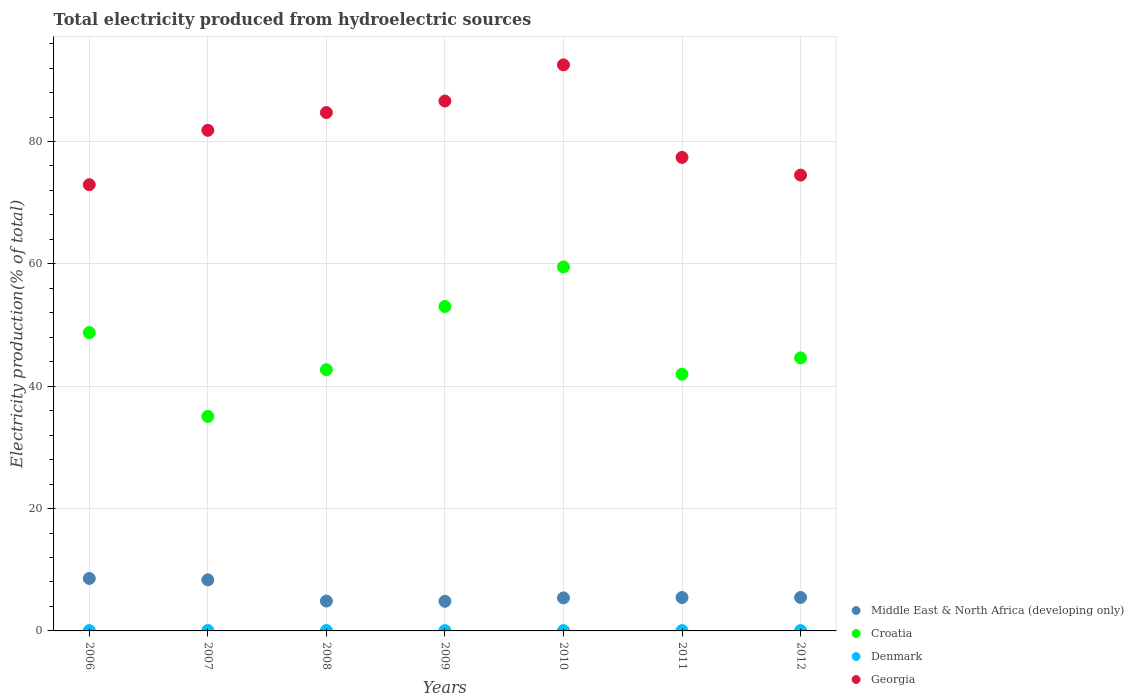How many different coloured dotlines are there?
Offer a terse response. 4. Is the number of dotlines equal to the number of legend labels?
Give a very brief answer. Yes. What is the total electricity produced in Croatia in 2011?
Ensure brevity in your answer.  41.96. Across all years, what is the maximum total electricity produced in Middle East & North Africa (developing only)?
Offer a terse response. 8.58. Across all years, what is the minimum total electricity produced in Georgia?
Provide a short and direct response. 72.94. In which year was the total electricity produced in Denmark maximum?
Make the answer very short. 2007. What is the total total electricity produced in Denmark in the graph?
Offer a very short reply. 0.4. What is the difference between the total electricity produced in Georgia in 2010 and that in 2011?
Make the answer very short. 15.12. What is the difference between the total electricity produced in Croatia in 2007 and the total electricity produced in Middle East & North Africa (developing only) in 2009?
Keep it short and to the point. 30.22. What is the average total electricity produced in Georgia per year?
Make the answer very short. 81.5. In the year 2006, what is the difference between the total electricity produced in Middle East & North Africa (developing only) and total electricity produced in Georgia?
Ensure brevity in your answer.  -64.36. In how many years, is the total electricity produced in Georgia greater than 48 %?
Keep it short and to the point. 7. What is the ratio of the total electricity produced in Croatia in 2006 to that in 2008?
Ensure brevity in your answer.  1.14. What is the difference between the highest and the second highest total electricity produced in Denmark?
Provide a short and direct response. 0. What is the difference between the highest and the lowest total electricity produced in Georgia?
Your answer should be very brief. 19.58. In how many years, is the total electricity produced in Georgia greater than the average total electricity produced in Georgia taken over all years?
Offer a terse response. 4. Is the sum of the total electricity produced in Middle East & North Africa (developing only) in 2010 and 2012 greater than the maximum total electricity produced in Denmark across all years?
Your answer should be very brief. Yes. Is it the case that in every year, the sum of the total electricity produced in Georgia and total electricity produced in Middle East & North Africa (developing only)  is greater than the total electricity produced in Denmark?
Keep it short and to the point. Yes. Does the total electricity produced in Denmark monotonically increase over the years?
Ensure brevity in your answer.  No. Is the total electricity produced in Middle East & North Africa (developing only) strictly greater than the total electricity produced in Georgia over the years?
Offer a very short reply. No. Is the total electricity produced in Middle East & North Africa (developing only) strictly less than the total electricity produced in Croatia over the years?
Your response must be concise. Yes. How many dotlines are there?
Ensure brevity in your answer.  4. How many years are there in the graph?
Ensure brevity in your answer.  7. Are the values on the major ticks of Y-axis written in scientific E-notation?
Your answer should be compact. No. Does the graph contain grids?
Give a very brief answer. Yes. How many legend labels are there?
Offer a very short reply. 4. What is the title of the graph?
Give a very brief answer. Total electricity produced from hydroelectric sources. What is the Electricity production(% of total) in Middle East & North Africa (developing only) in 2006?
Offer a terse response. 8.58. What is the Electricity production(% of total) in Croatia in 2006?
Provide a succinct answer. 48.76. What is the Electricity production(% of total) of Denmark in 2006?
Your response must be concise. 0.05. What is the Electricity production(% of total) of Georgia in 2006?
Your answer should be compact. 72.94. What is the Electricity production(% of total) of Middle East & North Africa (developing only) in 2007?
Provide a succinct answer. 8.34. What is the Electricity production(% of total) of Croatia in 2007?
Your response must be concise. 35.06. What is the Electricity production(% of total) of Denmark in 2007?
Keep it short and to the point. 0.07. What is the Electricity production(% of total) of Georgia in 2007?
Your answer should be compact. 81.83. What is the Electricity production(% of total) in Middle East & North Africa (developing only) in 2008?
Ensure brevity in your answer.  4.88. What is the Electricity production(% of total) in Croatia in 2008?
Offer a terse response. 42.7. What is the Electricity production(% of total) of Denmark in 2008?
Keep it short and to the point. 0.07. What is the Electricity production(% of total) of Georgia in 2008?
Keep it short and to the point. 84.73. What is the Electricity production(% of total) of Middle East & North Africa (developing only) in 2009?
Make the answer very short. 4.84. What is the Electricity production(% of total) in Croatia in 2009?
Offer a very short reply. 53.03. What is the Electricity production(% of total) of Denmark in 2009?
Give a very brief answer. 0.05. What is the Electricity production(% of total) of Georgia in 2009?
Your response must be concise. 86.61. What is the Electricity production(% of total) in Middle East & North Africa (developing only) in 2010?
Give a very brief answer. 5.4. What is the Electricity production(% of total) in Croatia in 2010?
Keep it short and to the point. 59.5. What is the Electricity production(% of total) in Denmark in 2010?
Provide a short and direct response. 0.05. What is the Electricity production(% of total) of Georgia in 2010?
Make the answer very short. 92.52. What is the Electricity production(% of total) in Middle East & North Africa (developing only) in 2011?
Keep it short and to the point. 5.45. What is the Electricity production(% of total) of Croatia in 2011?
Provide a succinct answer. 41.96. What is the Electricity production(% of total) in Denmark in 2011?
Your response must be concise. 0.05. What is the Electricity production(% of total) of Georgia in 2011?
Keep it short and to the point. 77.4. What is the Electricity production(% of total) of Middle East & North Africa (developing only) in 2012?
Give a very brief answer. 5.47. What is the Electricity production(% of total) in Croatia in 2012?
Provide a succinct answer. 44.63. What is the Electricity production(% of total) in Denmark in 2012?
Your answer should be compact. 0.06. What is the Electricity production(% of total) of Georgia in 2012?
Offer a terse response. 74.5. Across all years, what is the maximum Electricity production(% of total) of Middle East & North Africa (developing only)?
Make the answer very short. 8.58. Across all years, what is the maximum Electricity production(% of total) in Croatia?
Your answer should be compact. 59.5. Across all years, what is the maximum Electricity production(% of total) of Denmark?
Offer a very short reply. 0.07. Across all years, what is the maximum Electricity production(% of total) in Georgia?
Provide a succinct answer. 92.52. Across all years, what is the minimum Electricity production(% of total) in Middle East & North Africa (developing only)?
Give a very brief answer. 4.84. Across all years, what is the minimum Electricity production(% of total) in Croatia?
Your response must be concise. 35.06. Across all years, what is the minimum Electricity production(% of total) in Denmark?
Your answer should be very brief. 0.05. Across all years, what is the minimum Electricity production(% of total) in Georgia?
Your answer should be very brief. 72.94. What is the total Electricity production(% of total) in Middle East & North Africa (developing only) in the graph?
Your response must be concise. 42.97. What is the total Electricity production(% of total) of Croatia in the graph?
Give a very brief answer. 325.64. What is the total Electricity production(% of total) in Denmark in the graph?
Offer a very short reply. 0.4. What is the total Electricity production(% of total) in Georgia in the graph?
Give a very brief answer. 570.53. What is the difference between the Electricity production(% of total) in Middle East & North Africa (developing only) in 2006 and that in 2007?
Ensure brevity in your answer.  0.23. What is the difference between the Electricity production(% of total) of Croatia in 2006 and that in 2007?
Your response must be concise. 13.69. What is the difference between the Electricity production(% of total) of Denmark in 2006 and that in 2007?
Make the answer very short. -0.02. What is the difference between the Electricity production(% of total) in Georgia in 2006 and that in 2007?
Offer a terse response. -8.89. What is the difference between the Electricity production(% of total) in Middle East & North Africa (developing only) in 2006 and that in 2008?
Provide a succinct answer. 3.7. What is the difference between the Electricity production(% of total) in Croatia in 2006 and that in 2008?
Keep it short and to the point. 6.06. What is the difference between the Electricity production(% of total) in Denmark in 2006 and that in 2008?
Ensure brevity in your answer.  -0.02. What is the difference between the Electricity production(% of total) in Georgia in 2006 and that in 2008?
Your answer should be compact. -11.79. What is the difference between the Electricity production(% of total) of Middle East & North Africa (developing only) in 2006 and that in 2009?
Give a very brief answer. 3.74. What is the difference between the Electricity production(% of total) of Croatia in 2006 and that in 2009?
Provide a short and direct response. -4.27. What is the difference between the Electricity production(% of total) in Denmark in 2006 and that in 2009?
Your response must be concise. -0. What is the difference between the Electricity production(% of total) of Georgia in 2006 and that in 2009?
Keep it short and to the point. -13.67. What is the difference between the Electricity production(% of total) of Middle East & North Africa (developing only) in 2006 and that in 2010?
Ensure brevity in your answer.  3.18. What is the difference between the Electricity production(% of total) in Croatia in 2006 and that in 2010?
Your response must be concise. -10.74. What is the difference between the Electricity production(% of total) in Denmark in 2006 and that in 2010?
Offer a terse response. -0. What is the difference between the Electricity production(% of total) of Georgia in 2006 and that in 2010?
Ensure brevity in your answer.  -19.58. What is the difference between the Electricity production(% of total) in Middle East & North Africa (developing only) in 2006 and that in 2011?
Offer a very short reply. 3.12. What is the difference between the Electricity production(% of total) in Croatia in 2006 and that in 2011?
Your answer should be compact. 6.79. What is the difference between the Electricity production(% of total) in Denmark in 2006 and that in 2011?
Provide a succinct answer. 0. What is the difference between the Electricity production(% of total) of Georgia in 2006 and that in 2011?
Your answer should be compact. -4.46. What is the difference between the Electricity production(% of total) of Middle East & North Africa (developing only) in 2006 and that in 2012?
Your answer should be compact. 3.1. What is the difference between the Electricity production(% of total) of Croatia in 2006 and that in 2012?
Make the answer very short. 4.13. What is the difference between the Electricity production(% of total) in Denmark in 2006 and that in 2012?
Make the answer very short. -0. What is the difference between the Electricity production(% of total) of Georgia in 2006 and that in 2012?
Provide a short and direct response. -1.56. What is the difference between the Electricity production(% of total) in Middle East & North Africa (developing only) in 2007 and that in 2008?
Provide a succinct answer. 3.47. What is the difference between the Electricity production(% of total) of Croatia in 2007 and that in 2008?
Provide a succinct answer. -7.63. What is the difference between the Electricity production(% of total) in Denmark in 2007 and that in 2008?
Offer a very short reply. 0. What is the difference between the Electricity production(% of total) of Georgia in 2007 and that in 2008?
Offer a terse response. -2.9. What is the difference between the Electricity production(% of total) in Middle East & North Africa (developing only) in 2007 and that in 2009?
Offer a very short reply. 3.5. What is the difference between the Electricity production(% of total) in Croatia in 2007 and that in 2009?
Ensure brevity in your answer.  -17.97. What is the difference between the Electricity production(% of total) of Denmark in 2007 and that in 2009?
Your response must be concise. 0.02. What is the difference between the Electricity production(% of total) of Georgia in 2007 and that in 2009?
Your answer should be very brief. -4.78. What is the difference between the Electricity production(% of total) of Middle East & North Africa (developing only) in 2007 and that in 2010?
Give a very brief answer. 2.94. What is the difference between the Electricity production(% of total) in Croatia in 2007 and that in 2010?
Offer a terse response. -24.43. What is the difference between the Electricity production(% of total) in Denmark in 2007 and that in 2010?
Keep it short and to the point. 0.02. What is the difference between the Electricity production(% of total) of Georgia in 2007 and that in 2010?
Your answer should be very brief. -10.69. What is the difference between the Electricity production(% of total) in Middle East & North Africa (developing only) in 2007 and that in 2011?
Provide a succinct answer. 2.89. What is the difference between the Electricity production(% of total) of Croatia in 2007 and that in 2011?
Offer a terse response. -6.9. What is the difference between the Electricity production(% of total) of Denmark in 2007 and that in 2011?
Keep it short and to the point. 0.02. What is the difference between the Electricity production(% of total) in Georgia in 2007 and that in 2011?
Your response must be concise. 4.43. What is the difference between the Electricity production(% of total) in Middle East & North Africa (developing only) in 2007 and that in 2012?
Your answer should be very brief. 2.87. What is the difference between the Electricity production(% of total) in Croatia in 2007 and that in 2012?
Provide a succinct answer. -9.56. What is the difference between the Electricity production(% of total) of Denmark in 2007 and that in 2012?
Give a very brief answer. 0.02. What is the difference between the Electricity production(% of total) in Georgia in 2007 and that in 2012?
Give a very brief answer. 7.33. What is the difference between the Electricity production(% of total) of Middle East & North Africa (developing only) in 2008 and that in 2009?
Ensure brevity in your answer.  0.04. What is the difference between the Electricity production(% of total) of Croatia in 2008 and that in 2009?
Provide a short and direct response. -10.33. What is the difference between the Electricity production(% of total) of Denmark in 2008 and that in 2009?
Your answer should be compact. 0.02. What is the difference between the Electricity production(% of total) in Georgia in 2008 and that in 2009?
Your answer should be compact. -1.88. What is the difference between the Electricity production(% of total) of Middle East & North Africa (developing only) in 2008 and that in 2010?
Your response must be concise. -0.52. What is the difference between the Electricity production(% of total) in Croatia in 2008 and that in 2010?
Give a very brief answer. -16.8. What is the difference between the Electricity production(% of total) of Denmark in 2008 and that in 2010?
Your response must be concise. 0.02. What is the difference between the Electricity production(% of total) in Georgia in 2008 and that in 2010?
Offer a terse response. -7.8. What is the difference between the Electricity production(% of total) of Middle East & North Africa (developing only) in 2008 and that in 2011?
Offer a very short reply. -0.57. What is the difference between the Electricity production(% of total) in Croatia in 2008 and that in 2011?
Make the answer very short. 0.73. What is the difference between the Electricity production(% of total) in Denmark in 2008 and that in 2011?
Give a very brief answer. 0.02. What is the difference between the Electricity production(% of total) of Georgia in 2008 and that in 2011?
Your response must be concise. 7.33. What is the difference between the Electricity production(% of total) of Middle East & North Africa (developing only) in 2008 and that in 2012?
Your response must be concise. -0.59. What is the difference between the Electricity production(% of total) in Croatia in 2008 and that in 2012?
Keep it short and to the point. -1.93. What is the difference between the Electricity production(% of total) of Denmark in 2008 and that in 2012?
Your answer should be compact. 0.02. What is the difference between the Electricity production(% of total) of Georgia in 2008 and that in 2012?
Provide a succinct answer. 10.22. What is the difference between the Electricity production(% of total) in Middle East & North Africa (developing only) in 2009 and that in 2010?
Offer a very short reply. -0.56. What is the difference between the Electricity production(% of total) in Croatia in 2009 and that in 2010?
Your response must be concise. -6.47. What is the difference between the Electricity production(% of total) in Denmark in 2009 and that in 2010?
Provide a short and direct response. -0. What is the difference between the Electricity production(% of total) of Georgia in 2009 and that in 2010?
Provide a short and direct response. -5.91. What is the difference between the Electricity production(% of total) in Middle East & North Africa (developing only) in 2009 and that in 2011?
Give a very brief answer. -0.61. What is the difference between the Electricity production(% of total) in Croatia in 2009 and that in 2011?
Make the answer very short. 11.07. What is the difference between the Electricity production(% of total) of Denmark in 2009 and that in 2011?
Make the answer very short. 0. What is the difference between the Electricity production(% of total) in Georgia in 2009 and that in 2011?
Provide a succinct answer. 9.21. What is the difference between the Electricity production(% of total) of Middle East & North Africa (developing only) in 2009 and that in 2012?
Offer a very short reply. -0.63. What is the difference between the Electricity production(% of total) in Croatia in 2009 and that in 2012?
Provide a succinct answer. 8.4. What is the difference between the Electricity production(% of total) of Denmark in 2009 and that in 2012?
Offer a terse response. -0. What is the difference between the Electricity production(% of total) in Georgia in 2009 and that in 2012?
Provide a succinct answer. 12.11. What is the difference between the Electricity production(% of total) in Middle East & North Africa (developing only) in 2010 and that in 2011?
Offer a very short reply. -0.05. What is the difference between the Electricity production(% of total) in Croatia in 2010 and that in 2011?
Your answer should be very brief. 17.53. What is the difference between the Electricity production(% of total) in Denmark in 2010 and that in 2011?
Ensure brevity in your answer.  0.01. What is the difference between the Electricity production(% of total) of Georgia in 2010 and that in 2011?
Your answer should be very brief. 15.12. What is the difference between the Electricity production(% of total) in Middle East & North Africa (developing only) in 2010 and that in 2012?
Your answer should be very brief. -0.07. What is the difference between the Electricity production(% of total) in Croatia in 2010 and that in 2012?
Give a very brief answer. 14.87. What is the difference between the Electricity production(% of total) in Denmark in 2010 and that in 2012?
Offer a very short reply. -0. What is the difference between the Electricity production(% of total) of Georgia in 2010 and that in 2012?
Offer a very short reply. 18.02. What is the difference between the Electricity production(% of total) of Middle East & North Africa (developing only) in 2011 and that in 2012?
Offer a terse response. -0.02. What is the difference between the Electricity production(% of total) of Croatia in 2011 and that in 2012?
Give a very brief answer. -2.66. What is the difference between the Electricity production(% of total) of Denmark in 2011 and that in 2012?
Your answer should be very brief. -0.01. What is the difference between the Electricity production(% of total) in Georgia in 2011 and that in 2012?
Ensure brevity in your answer.  2.9. What is the difference between the Electricity production(% of total) of Middle East & North Africa (developing only) in 2006 and the Electricity production(% of total) of Croatia in 2007?
Your answer should be compact. -26.49. What is the difference between the Electricity production(% of total) of Middle East & North Africa (developing only) in 2006 and the Electricity production(% of total) of Denmark in 2007?
Your answer should be very brief. 8.51. What is the difference between the Electricity production(% of total) of Middle East & North Africa (developing only) in 2006 and the Electricity production(% of total) of Georgia in 2007?
Provide a short and direct response. -73.25. What is the difference between the Electricity production(% of total) of Croatia in 2006 and the Electricity production(% of total) of Denmark in 2007?
Your response must be concise. 48.69. What is the difference between the Electricity production(% of total) in Croatia in 2006 and the Electricity production(% of total) in Georgia in 2007?
Offer a very short reply. -33.07. What is the difference between the Electricity production(% of total) of Denmark in 2006 and the Electricity production(% of total) of Georgia in 2007?
Give a very brief answer. -81.78. What is the difference between the Electricity production(% of total) of Middle East & North Africa (developing only) in 2006 and the Electricity production(% of total) of Croatia in 2008?
Provide a short and direct response. -34.12. What is the difference between the Electricity production(% of total) in Middle East & North Africa (developing only) in 2006 and the Electricity production(% of total) in Denmark in 2008?
Ensure brevity in your answer.  8.51. What is the difference between the Electricity production(% of total) in Middle East & North Africa (developing only) in 2006 and the Electricity production(% of total) in Georgia in 2008?
Ensure brevity in your answer.  -76.15. What is the difference between the Electricity production(% of total) of Croatia in 2006 and the Electricity production(% of total) of Denmark in 2008?
Provide a succinct answer. 48.69. What is the difference between the Electricity production(% of total) in Croatia in 2006 and the Electricity production(% of total) in Georgia in 2008?
Provide a short and direct response. -35.97. What is the difference between the Electricity production(% of total) of Denmark in 2006 and the Electricity production(% of total) of Georgia in 2008?
Make the answer very short. -84.68. What is the difference between the Electricity production(% of total) of Middle East & North Africa (developing only) in 2006 and the Electricity production(% of total) of Croatia in 2009?
Provide a succinct answer. -44.45. What is the difference between the Electricity production(% of total) in Middle East & North Africa (developing only) in 2006 and the Electricity production(% of total) in Denmark in 2009?
Your answer should be compact. 8.53. What is the difference between the Electricity production(% of total) in Middle East & North Africa (developing only) in 2006 and the Electricity production(% of total) in Georgia in 2009?
Make the answer very short. -78.03. What is the difference between the Electricity production(% of total) in Croatia in 2006 and the Electricity production(% of total) in Denmark in 2009?
Give a very brief answer. 48.7. What is the difference between the Electricity production(% of total) in Croatia in 2006 and the Electricity production(% of total) in Georgia in 2009?
Provide a succinct answer. -37.85. What is the difference between the Electricity production(% of total) in Denmark in 2006 and the Electricity production(% of total) in Georgia in 2009?
Offer a very short reply. -86.56. What is the difference between the Electricity production(% of total) in Middle East & North Africa (developing only) in 2006 and the Electricity production(% of total) in Croatia in 2010?
Your answer should be compact. -50.92. What is the difference between the Electricity production(% of total) of Middle East & North Africa (developing only) in 2006 and the Electricity production(% of total) of Denmark in 2010?
Provide a succinct answer. 8.52. What is the difference between the Electricity production(% of total) in Middle East & North Africa (developing only) in 2006 and the Electricity production(% of total) in Georgia in 2010?
Offer a terse response. -83.95. What is the difference between the Electricity production(% of total) in Croatia in 2006 and the Electricity production(% of total) in Denmark in 2010?
Provide a succinct answer. 48.7. What is the difference between the Electricity production(% of total) of Croatia in 2006 and the Electricity production(% of total) of Georgia in 2010?
Give a very brief answer. -43.77. What is the difference between the Electricity production(% of total) in Denmark in 2006 and the Electricity production(% of total) in Georgia in 2010?
Provide a short and direct response. -92.47. What is the difference between the Electricity production(% of total) of Middle East & North Africa (developing only) in 2006 and the Electricity production(% of total) of Croatia in 2011?
Your answer should be very brief. -33.39. What is the difference between the Electricity production(% of total) of Middle East & North Africa (developing only) in 2006 and the Electricity production(% of total) of Denmark in 2011?
Ensure brevity in your answer.  8.53. What is the difference between the Electricity production(% of total) in Middle East & North Africa (developing only) in 2006 and the Electricity production(% of total) in Georgia in 2011?
Provide a short and direct response. -68.82. What is the difference between the Electricity production(% of total) of Croatia in 2006 and the Electricity production(% of total) of Denmark in 2011?
Your response must be concise. 48.71. What is the difference between the Electricity production(% of total) in Croatia in 2006 and the Electricity production(% of total) in Georgia in 2011?
Your answer should be compact. -28.64. What is the difference between the Electricity production(% of total) in Denmark in 2006 and the Electricity production(% of total) in Georgia in 2011?
Your answer should be very brief. -77.35. What is the difference between the Electricity production(% of total) of Middle East & North Africa (developing only) in 2006 and the Electricity production(% of total) of Croatia in 2012?
Make the answer very short. -36.05. What is the difference between the Electricity production(% of total) in Middle East & North Africa (developing only) in 2006 and the Electricity production(% of total) in Denmark in 2012?
Make the answer very short. 8.52. What is the difference between the Electricity production(% of total) of Middle East & North Africa (developing only) in 2006 and the Electricity production(% of total) of Georgia in 2012?
Keep it short and to the point. -65.92. What is the difference between the Electricity production(% of total) of Croatia in 2006 and the Electricity production(% of total) of Denmark in 2012?
Offer a terse response. 48.7. What is the difference between the Electricity production(% of total) of Croatia in 2006 and the Electricity production(% of total) of Georgia in 2012?
Provide a short and direct response. -25.75. What is the difference between the Electricity production(% of total) of Denmark in 2006 and the Electricity production(% of total) of Georgia in 2012?
Make the answer very short. -74.45. What is the difference between the Electricity production(% of total) in Middle East & North Africa (developing only) in 2007 and the Electricity production(% of total) in Croatia in 2008?
Ensure brevity in your answer.  -34.35. What is the difference between the Electricity production(% of total) in Middle East & North Africa (developing only) in 2007 and the Electricity production(% of total) in Denmark in 2008?
Offer a terse response. 8.27. What is the difference between the Electricity production(% of total) of Middle East & North Africa (developing only) in 2007 and the Electricity production(% of total) of Georgia in 2008?
Keep it short and to the point. -76.38. What is the difference between the Electricity production(% of total) of Croatia in 2007 and the Electricity production(% of total) of Denmark in 2008?
Your answer should be very brief. 34.99. What is the difference between the Electricity production(% of total) of Croatia in 2007 and the Electricity production(% of total) of Georgia in 2008?
Your answer should be very brief. -49.66. What is the difference between the Electricity production(% of total) of Denmark in 2007 and the Electricity production(% of total) of Georgia in 2008?
Offer a terse response. -84.66. What is the difference between the Electricity production(% of total) of Middle East & North Africa (developing only) in 2007 and the Electricity production(% of total) of Croatia in 2009?
Give a very brief answer. -44.69. What is the difference between the Electricity production(% of total) of Middle East & North Africa (developing only) in 2007 and the Electricity production(% of total) of Denmark in 2009?
Provide a succinct answer. 8.29. What is the difference between the Electricity production(% of total) in Middle East & North Africa (developing only) in 2007 and the Electricity production(% of total) in Georgia in 2009?
Provide a succinct answer. -78.26. What is the difference between the Electricity production(% of total) of Croatia in 2007 and the Electricity production(% of total) of Denmark in 2009?
Make the answer very short. 35.01. What is the difference between the Electricity production(% of total) of Croatia in 2007 and the Electricity production(% of total) of Georgia in 2009?
Provide a succinct answer. -51.55. What is the difference between the Electricity production(% of total) in Denmark in 2007 and the Electricity production(% of total) in Georgia in 2009?
Make the answer very short. -86.54. What is the difference between the Electricity production(% of total) of Middle East & North Africa (developing only) in 2007 and the Electricity production(% of total) of Croatia in 2010?
Keep it short and to the point. -51.15. What is the difference between the Electricity production(% of total) in Middle East & North Africa (developing only) in 2007 and the Electricity production(% of total) in Denmark in 2010?
Offer a very short reply. 8.29. What is the difference between the Electricity production(% of total) of Middle East & North Africa (developing only) in 2007 and the Electricity production(% of total) of Georgia in 2010?
Offer a terse response. -84.18. What is the difference between the Electricity production(% of total) of Croatia in 2007 and the Electricity production(% of total) of Denmark in 2010?
Offer a terse response. 35.01. What is the difference between the Electricity production(% of total) of Croatia in 2007 and the Electricity production(% of total) of Georgia in 2010?
Provide a short and direct response. -57.46. What is the difference between the Electricity production(% of total) of Denmark in 2007 and the Electricity production(% of total) of Georgia in 2010?
Your answer should be very brief. -92.45. What is the difference between the Electricity production(% of total) in Middle East & North Africa (developing only) in 2007 and the Electricity production(% of total) in Croatia in 2011?
Make the answer very short. -33.62. What is the difference between the Electricity production(% of total) of Middle East & North Africa (developing only) in 2007 and the Electricity production(% of total) of Denmark in 2011?
Offer a very short reply. 8.3. What is the difference between the Electricity production(% of total) of Middle East & North Africa (developing only) in 2007 and the Electricity production(% of total) of Georgia in 2011?
Your answer should be compact. -69.05. What is the difference between the Electricity production(% of total) in Croatia in 2007 and the Electricity production(% of total) in Denmark in 2011?
Your answer should be compact. 35.02. What is the difference between the Electricity production(% of total) of Croatia in 2007 and the Electricity production(% of total) of Georgia in 2011?
Offer a terse response. -42.34. What is the difference between the Electricity production(% of total) of Denmark in 2007 and the Electricity production(% of total) of Georgia in 2011?
Provide a short and direct response. -77.33. What is the difference between the Electricity production(% of total) in Middle East & North Africa (developing only) in 2007 and the Electricity production(% of total) in Croatia in 2012?
Your answer should be compact. -36.28. What is the difference between the Electricity production(% of total) in Middle East & North Africa (developing only) in 2007 and the Electricity production(% of total) in Denmark in 2012?
Offer a very short reply. 8.29. What is the difference between the Electricity production(% of total) of Middle East & North Africa (developing only) in 2007 and the Electricity production(% of total) of Georgia in 2012?
Offer a very short reply. -66.16. What is the difference between the Electricity production(% of total) of Croatia in 2007 and the Electricity production(% of total) of Denmark in 2012?
Keep it short and to the point. 35.01. What is the difference between the Electricity production(% of total) in Croatia in 2007 and the Electricity production(% of total) in Georgia in 2012?
Ensure brevity in your answer.  -39.44. What is the difference between the Electricity production(% of total) of Denmark in 2007 and the Electricity production(% of total) of Georgia in 2012?
Make the answer very short. -74.43. What is the difference between the Electricity production(% of total) in Middle East & North Africa (developing only) in 2008 and the Electricity production(% of total) in Croatia in 2009?
Provide a short and direct response. -48.15. What is the difference between the Electricity production(% of total) of Middle East & North Africa (developing only) in 2008 and the Electricity production(% of total) of Denmark in 2009?
Provide a short and direct response. 4.83. What is the difference between the Electricity production(% of total) of Middle East & North Africa (developing only) in 2008 and the Electricity production(% of total) of Georgia in 2009?
Provide a succinct answer. -81.73. What is the difference between the Electricity production(% of total) in Croatia in 2008 and the Electricity production(% of total) in Denmark in 2009?
Make the answer very short. 42.65. What is the difference between the Electricity production(% of total) in Croatia in 2008 and the Electricity production(% of total) in Georgia in 2009?
Offer a terse response. -43.91. What is the difference between the Electricity production(% of total) in Denmark in 2008 and the Electricity production(% of total) in Georgia in 2009?
Keep it short and to the point. -86.54. What is the difference between the Electricity production(% of total) of Middle East & North Africa (developing only) in 2008 and the Electricity production(% of total) of Croatia in 2010?
Keep it short and to the point. -54.62. What is the difference between the Electricity production(% of total) in Middle East & North Africa (developing only) in 2008 and the Electricity production(% of total) in Denmark in 2010?
Your response must be concise. 4.83. What is the difference between the Electricity production(% of total) of Middle East & North Africa (developing only) in 2008 and the Electricity production(% of total) of Georgia in 2010?
Offer a terse response. -87.64. What is the difference between the Electricity production(% of total) in Croatia in 2008 and the Electricity production(% of total) in Denmark in 2010?
Make the answer very short. 42.64. What is the difference between the Electricity production(% of total) of Croatia in 2008 and the Electricity production(% of total) of Georgia in 2010?
Keep it short and to the point. -49.82. What is the difference between the Electricity production(% of total) in Denmark in 2008 and the Electricity production(% of total) in Georgia in 2010?
Make the answer very short. -92.45. What is the difference between the Electricity production(% of total) in Middle East & North Africa (developing only) in 2008 and the Electricity production(% of total) in Croatia in 2011?
Make the answer very short. -37.08. What is the difference between the Electricity production(% of total) of Middle East & North Africa (developing only) in 2008 and the Electricity production(% of total) of Denmark in 2011?
Provide a succinct answer. 4.83. What is the difference between the Electricity production(% of total) of Middle East & North Africa (developing only) in 2008 and the Electricity production(% of total) of Georgia in 2011?
Your response must be concise. -72.52. What is the difference between the Electricity production(% of total) in Croatia in 2008 and the Electricity production(% of total) in Denmark in 2011?
Your answer should be very brief. 42.65. What is the difference between the Electricity production(% of total) in Croatia in 2008 and the Electricity production(% of total) in Georgia in 2011?
Give a very brief answer. -34.7. What is the difference between the Electricity production(% of total) in Denmark in 2008 and the Electricity production(% of total) in Georgia in 2011?
Offer a terse response. -77.33. What is the difference between the Electricity production(% of total) in Middle East & North Africa (developing only) in 2008 and the Electricity production(% of total) in Croatia in 2012?
Make the answer very short. -39.75. What is the difference between the Electricity production(% of total) in Middle East & North Africa (developing only) in 2008 and the Electricity production(% of total) in Denmark in 2012?
Provide a succinct answer. 4.82. What is the difference between the Electricity production(% of total) in Middle East & North Africa (developing only) in 2008 and the Electricity production(% of total) in Georgia in 2012?
Make the answer very short. -69.62. What is the difference between the Electricity production(% of total) in Croatia in 2008 and the Electricity production(% of total) in Denmark in 2012?
Provide a succinct answer. 42.64. What is the difference between the Electricity production(% of total) in Croatia in 2008 and the Electricity production(% of total) in Georgia in 2012?
Provide a short and direct response. -31.8. What is the difference between the Electricity production(% of total) of Denmark in 2008 and the Electricity production(% of total) of Georgia in 2012?
Offer a very short reply. -74.43. What is the difference between the Electricity production(% of total) of Middle East & North Africa (developing only) in 2009 and the Electricity production(% of total) of Croatia in 2010?
Your answer should be very brief. -54.65. What is the difference between the Electricity production(% of total) in Middle East & North Africa (developing only) in 2009 and the Electricity production(% of total) in Denmark in 2010?
Ensure brevity in your answer.  4.79. What is the difference between the Electricity production(% of total) in Middle East & North Africa (developing only) in 2009 and the Electricity production(% of total) in Georgia in 2010?
Make the answer very short. -87.68. What is the difference between the Electricity production(% of total) of Croatia in 2009 and the Electricity production(% of total) of Denmark in 2010?
Provide a succinct answer. 52.98. What is the difference between the Electricity production(% of total) in Croatia in 2009 and the Electricity production(% of total) in Georgia in 2010?
Offer a very short reply. -39.49. What is the difference between the Electricity production(% of total) in Denmark in 2009 and the Electricity production(% of total) in Georgia in 2010?
Provide a short and direct response. -92.47. What is the difference between the Electricity production(% of total) of Middle East & North Africa (developing only) in 2009 and the Electricity production(% of total) of Croatia in 2011?
Your answer should be very brief. -37.12. What is the difference between the Electricity production(% of total) in Middle East & North Africa (developing only) in 2009 and the Electricity production(% of total) in Denmark in 2011?
Offer a terse response. 4.79. What is the difference between the Electricity production(% of total) of Middle East & North Africa (developing only) in 2009 and the Electricity production(% of total) of Georgia in 2011?
Offer a very short reply. -72.56. What is the difference between the Electricity production(% of total) in Croatia in 2009 and the Electricity production(% of total) in Denmark in 2011?
Provide a short and direct response. 52.98. What is the difference between the Electricity production(% of total) of Croatia in 2009 and the Electricity production(% of total) of Georgia in 2011?
Your answer should be compact. -24.37. What is the difference between the Electricity production(% of total) of Denmark in 2009 and the Electricity production(% of total) of Georgia in 2011?
Give a very brief answer. -77.35. What is the difference between the Electricity production(% of total) in Middle East & North Africa (developing only) in 2009 and the Electricity production(% of total) in Croatia in 2012?
Keep it short and to the point. -39.78. What is the difference between the Electricity production(% of total) of Middle East & North Africa (developing only) in 2009 and the Electricity production(% of total) of Denmark in 2012?
Make the answer very short. 4.79. What is the difference between the Electricity production(% of total) of Middle East & North Africa (developing only) in 2009 and the Electricity production(% of total) of Georgia in 2012?
Make the answer very short. -69.66. What is the difference between the Electricity production(% of total) of Croatia in 2009 and the Electricity production(% of total) of Denmark in 2012?
Ensure brevity in your answer.  52.97. What is the difference between the Electricity production(% of total) in Croatia in 2009 and the Electricity production(% of total) in Georgia in 2012?
Your answer should be very brief. -21.47. What is the difference between the Electricity production(% of total) in Denmark in 2009 and the Electricity production(% of total) in Georgia in 2012?
Ensure brevity in your answer.  -74.45. What is the difference between the Electricity production(% of total) in Middle East & North Africa (developing only) in 2010 and the Electricity production(% of total) in Croatia in 2011?
Give a very brief answer. -36.56. What is the difference between the Electricity production(% of total) in Middle East & North Africa (developing only) in 2010 and the Electricity production(% of total) in Denmark in 2011?
Give a very brief answer. 5.35. What is the difference between the Electricity production(% of total) in Middle East & North Africa (developing only) in 2010 and the Electricity production(% of total) in Georgia in 2011?
Make the answer very short. -72. What is the difference between the Electricity production(% of total) in Croatia in 2010 and the Electricity production(% of total) in Denmark in 2011?
Give a very brief answer. 59.45. What is the difference between the Electricity production(% of total) of Croatia in 2010 and the Electricity production(% of total) of Georgia in 2011?
Provide a short and direct response. -17.9. What is the difference between the Electricity production(% of total) in Denmark in 2010 and the Electricity production(% of total) in Georgia in 2011?
Provide a short and direct response. -77.34. What is the difference between the Electricity production(% of total) of Middle East & North Africa (developing only) in 2010 and the Electricity production(% of total) of Croatia in 2012?
Make the answer very short. -39.23. What is the difference between the Electricity production(% of total) in Middle East & North Africa (developing only) in 2010 and the Electricity production(% of total) in Denmark in 2012?
Offer a very short reply. 5.35. What is the difference between the Electricity production(% of total) in Middle East & North Africa (developing only) in 2010 and the Electricity production(% of total) in Georgia in 2012?
Your answer should be compact. -69.1. What is the difference between the Electricity production(% of total) in Croatia in 2010 and the Electricity production(% of total) in Denmark in 2012?
Give a very brief answer. 59.44. What is the difference between the Electricity production(% of total) in Croatia in 2010 and the Electricity production(% of total) in Georgia in 2012?
Make the answer very short. -15.01. What is the difference between the Electricity production(% of total) of Denmark in 2010 and the Electricity production(% of total) of Georgia in 2012?
Offer a very short reply. -74.45. What is the difference between the Electricity production(% of total) of Middle East & North Africa (developing only) in 2011 and the Electricity production(% of total) of Croatia in 2012?
Keep it short and to the point. -39.17. What is the difference between the Electricity production(% of total) in Middle East & North Africa (developing only) in 2011 and the Electricity production(% of total) in Denmark in 2012?
Keep it short and to the point. 5.4. What is the difference between the Electricity production(% of total) of Middle East & North Africa (developing only) in 2011 and the Electricity production(% of total) of Georgia in 2012?
Your response must be concise. -69.05. What is the difference between the Electricity production(% of total) in Croatia in 2011 and the Electricity production(% of total) in Denmark in 2012?
Your answer should be very brief. 41.91. What is the difference between the Electricity production(% of total) in Croatia in 2011 and the Electricity production(% of total) in Georgia in 2012?
Ensure brevity in your answer.  -32.54. What is the difference between the Electricity production(% of total) of Denmark in 2011 and the Electricity production(% of total) of Georgia in 2012?
Offer a very short reply. -74.45. What is the average Electricity production(% of total) of Middle East & North Africa (developing only) per year?
Offer a terse response. 6.14. What is the average Electricity production(% of total) of Croatia per year?
Your answer should be compact. 46.52. What is the average Electricity production(% of total) of Denmark per year?
Your response must be concise. 0.06. What is the average Electricity production(% of total) of Georgia per year?
Provide a short and direct response. 81.5. In the year 2006, what is the difference between the Electricity production(% of total) in Middle East & North Africa (developing only) and Electricity production(% of total) in Croatia?
Provide a short and direct response. -40.18. In the year 2006, what is the difference between the Electricity production(% of total) in Middle East & North Africa (developing only) and Electricity production(% of total) in Denmark?
Your answer should be very brief. 8.53. In the year 2006, what is the difference between the Electricity production(% of total) in Middle East & North Africa (developing only) and Electricity production(% of total) in Georgia?
Offer a terse response. -64.36. In the year 2006, what is the difference between the Electricity production(% of total) in Croatia and Electricity production(% of total) in Denmark?
Your answer should be very brief. 48.71. In the year 2006, what is the difference between the Electricity production(% of total) in Croatia and Electricity production(% of total) in Georgia?
Offer a terse response. -24.18. In the year 2006, what is the difference between the Electricity production(% of total) of Denmark and Electricity production(% of total) of Georgia?
Your answer should be very brief. -72.89. In the year 2007, what is the difference between the Electricity production(% of total) of Middle East & North Africa (developing only) and Electricity production(% of total) of Croatia?
Provide a succinct answer. -26.72. In the year 2007, what is the difference between the Electricity production(% of total) in Middle East & North Africa (developing only) and Electricity production(% of total) in Denmark?
Ensure brevity in your answer.  8.27. In the year 2007, what is the difference between the Electricity production(% of total) in Middle East & North Africa (developing only) and Electricity production(% of total) in Georgia?
Provide a succinct answer. -73.48. In the year 2007, what is the difference between the Electricity production(% of total) in Croatia and Electricity production(% of total) in Denmark?
Keep it short and to the point. 34.99. In the year 2007, what is the difference between the Electricity production(% of total) of Croatia and Electricity production(% of total) of Georgia?
Your answer should be compact. -46.77. In the year 2007, what is the difference between the Electricity production(% of total) of Denmark and Electricity production(% of total) of Georgia?
Your answer should be very brief. -81.76. In the year 2008, what is the difference between the Electricity production(% of total) of Middle East & North Africa (developing only) and Electricity production(% of total) of Croatia?
Make the answer very short. -37.82. In the year 2008, what is the difference between the Electricity production(% of total) in Middle East & North Africa (developing only) and Electricity production(% of total) in Denmark?
Keep it short and to the point. 4.81. In the year 2008, what is the difference between the Electricity production(% of total) in Middle East & North Africa (developing only) and Electricity production(% of total) in Georgia?
Offer a terse response. -79.85. In the year 2008, what is the difference between the Electricity production(% of total) of Croatia and Electricity production(% of total) of Denmark?
Your answer should be very brief. 42.63. In the year 2008, what is the difference between the Electricity production(% of total) in Croatia and Electricity production(% of total) in Georgia?
Keep it short and to the point. -42.03. In the year 2008, what is the difference between the Electricity production(% of total) of Denmark and Electricity production(% of total) of Georgia?
Your response must be concise. -84.66. In the year 2009, what is the difference between the Electricity production(% of total) of Middle East & North Africa (developing only) and Electricity production(% of total) of Croatia?
Ensure brevity in your answer.  -48.19. In the year 2009, what is the difference between the Electricity production(% of total) of Middle East & North Africa (developing only) and Electricity production(% of total) of Denmark?
Your answer should be compact. 4.79. In the year 2009, what is the difference between the Electricity production(% of total) in Middle East & North Africa (developing only) and Electricity production(% of total) in Georgia?
Provide a succinct answer. -81.77. In the year 2009, what is the difference between the Electricity production(% of total) in Croatia and Electricity production(% of total) in Denmark?
Ensure brevity in your answer.  52.98. In the year 2009, what is the difference between the Electricity production(% of total) of Croatia and Electricity production(% of total) of Georgia?
Your answer should be very brief. -33.58. In the year 2009, what is the difference between the Electricity production(% of total) of Denmark and Electricity production(% of total) of Georgia?
Keep it short and to the point. -86.56. In the year 2010, what is the difference between the Electricity production(% of total) in Middle East & North Africa (developing only) and Electricity production(% of total) in Croatia?
Provide a succinct answer. -54.09. In the year 2010, what is the difference between the Electricity production(% of total) in Middle East & North Africa (developing only) and Electricity production(% of total) in Denmark?
Offer a terse response. 5.35. In the year 2010, what is the difference between the Electricity production(% of total) in Middle East & North Africa (developing only) and Electricity production(% of total) in Georgia?
Give a very brief answer. -87.12. In the year 2010, what is the difference between the Electricity production(% of total) of Croatia and Electricity production(% of total) of Denmark?
Offer a very short reply. 59.44. In the year 2010, what is the difference between the Electricity production(% of total) of Croatia and Electricity production(% of total) of Georgia?
Make the answer very short. -33.03. In the year 2010, what is the difference between the Electricity production(% of total) of Denmark and Electricity production(% of total) of Georgia?
Offer a terse response. -92.47. In the year 2011, what is the difference between the Electricity production(% of total) of Middle East & North Africa (developing only) and Electricity production(% of total) of Croatia?
Ensure brevity in your answer.  -36.51. In the year 2011, what is the difference between the Electricity production(% of total) in Middle East & North Africa (developing only) and Electricity production(% of total) in Denmark?
Ensure brevity in your answer.  5.41. In the year 2011, what is the difference between the Electricity production(% of total) in Middle East & North Africa (developing only) and Electricity production(% of total) in Georgia?
Offer a terse response. -71.94. In the year 2011, what is the difference between the Electricity production(% of total) in Croatia and Electricity production(% of total) in Denmark?
Provide a short and direct response. 41.92. In the year 2011, what is the difference between the Electricity production(% of total) in Croatia and Electricity production(% of total) in Georgia?
Provide a succinct answer. -35.43. In the year 2011, what is the difference between the Electricity production(% of total) of Denmark and Electricity production(% of total) of Georgia?
Offer a terse response. -77.35. In the year 2012, what is the difference between the Electricity production(% of total) in Middle East & North Africa (developing only) and Electricity production(% of total) in Croatia?
Give a very brief answer. -39.15. In the year 2012, what is the difference between the Electricity production(% of total) in Middle East & North Africa (developing only) and Electricity production(% of total) in Denmark?
Give a very brief answer. 5.42. In the year 2012, what is the difference between the Electricity production(% of total) in Middle East & North Africa (developing only) and Electricity production(% of total) in Georgia?
Keep it short and to the point. -69.03. In the year 2012, what is the difference between the Electricity production(% of total) in Croatia and Electricity production(% of total) in Denmark?
Your answer should be compact. 44.57. In the year 2012, what is the difference between the Electricity production(% of total) of Croatia and Electricity production(% of total) of Georgia?
Make the answer very short. -29.88. In the year 2012, what is the difference between the Electricity production(% of total) in Denmark and Electricity production(% of total) in Georgia?
Offer a terse response. -74.45. What is the ratio of the Electricity production(% of total) of Middle East & North Africa (developing only) in 2006 to that in 2007?
Provide a short and direct response. 1.03. What is the ratio of the Electricity production(% of total) of Croatia in 2006 to that in 2007?
Your response must be concise. 1.39. What is the ratio of the Electricity production(% of total) in Denmark in 2006 to that in 2007?
Provide a short and direct response. 0.71. What is the ratio of the Electricity production(% of total) of Georgia in 2006 to that in 2007?
Keep it short and to the point. 0.89. What is the ratio of the Electricity production(% of total) in Middle East & North Africa (developing only) in 2006 to that in 2008?
Your response must be concise. 1.76. What is the ratio of the Electricity production(% of total) of Croatia in 2006 to that in 2008?
Offer a terse response. 1.14. What is the ratio of the Electricity production(% of total) in Denmark in 2006 to that in 2008?
Your answer should be very brief. 0.71. What is the ratio of the Electricity production(% of total) of Georgia in 2006 to that in 2008?
Offer a terse response. 0.86. What is the ratio of the Electricity production(% of total) in Middle East & North Africa (developing only) in 2006 to that in 2009?
Your answer should be very brief. 1.77. What is the ratio of the Electricity production(% of total) in Croatia in 2006 to that in 2009?
Provide a succinct answer. 0.92. What is the ratio of the Electricity production(% of total) in Denmark in 2006 to that in 2009?
Offer a very short reply. 0.97. What is the ratio of the Electricity production(% of total) of Georgia in 2006 to that in 2009?
Your answer should be compact. 0.84. What is the ratio of the Electricity production(% of total) of Middle East & North Africa (developing only) in 2006 to that in 2010?
Make the answer very short. 1.59. What is the ratio of the Electricity production(% of total) in Croatia in 2006 to that in 2010?
Keep it short and to the point. 0.82. What is the ratio of the Electricity production(% of total) in Denmark in 2006 to that in 2010?
Offer a very short reply. 0.93. What is the ratio of the Electricity production(% of total) in Georgia in 2006 to that in 2010?
Your answer should be compact. 0.79. What is the ratio of the Electricity production(% of total) of Middle East & North Africa (developing only) in 2006 to that in 2011?
Provide a short and direct response. 1.57. What is the ratio of the Electricity production(% of total) in Croatia in 2006 to that in 2011?
Make the answer very short. 1.16. What is the ratio of the Electricity production(% of total) in Denmark in 2006 to that in 2011?
Ensure brevity in your answer.  1.05. What is the ratio of the Electricity production(% of total) of Georgia in 2006 to that in 2011?
Keep it short and to the point. 0.94. What is the ratio of the Electricity production(% of total) in Middle East & North Africa (developing only) in 2006 to that in 2012?
Your answer should be compact. 1.57. What is the ratio of the Electricity production(% of total) in Croatia in 2006 to that in 2012?
Make the answer very short. 1.09. What is the ratio of the Electricity production(% of total) in Denmark in 2006 to that in 2012?
Your answer should be very brief. 0.91. What is the ratio of the Electricity production(% of total) of Georgia in 2006 to that in 2012?
Your answer should be compact. 0.98. What is the ratio of the Electricity production(% of total) in Middle East & North Africa (developing only) in 2007 to that in 2008?
Provide a short and direct response. 1.71. What is the ratio of the Electricity production(% of total) in Croatia in 2007 to that in 2008?
Keep it short and to the point. 0.82. What is the ratio of the Electricity production(% of total) of Denmark in 2007 to that in 2008?
Provide a succinct answer. 1. What is the ratio of the Electricity production(% of total) of Georgia in 2007 to that in 2008?
Your answer should be very brief. 0.97. What is the ratio of the Electricity production(% of total) in Middle East & North Africa (developing only) in 2007 to that in 2009?
Your answer should be very brief. 1.72. What is the ratio of the Electricity production(% of total) in Croatia in 2007 to that in 2009?
Give a very brief answer. 0.66. What is the ratio of the Electricity production(% of total) in Denmark in 2007 to that in 2009?
Keep it short and to the point. 1.36. What is the ratio of the Electricity production(% of total) in Georgia in 2007 to that in 2009?
Offer a terse response. 0.94. What is the ratio of the Electricity production(% of total) in Middle East & North Africa (developing only) in 2007 to that in 2010?
Make the answer very short. 1.54. What is the ratio of the Electricity production(% of total) of Croatia in 2007 to that in 2010?
Your answer should be compact. 0.59. What is the ratio of the Electricity production(% of total) in Denmark in 2007 to that in 2010?
Offer a very short reply. 1.32. What is the ratio of the Electricity production(% of total) of Georgia in 2007 to that in 2010?
Your response must be concise. 0.88. What is the ratio of the Electricity production(% of total) in Middle East & North Africa (developing only) in 2007 to that in 2011?
Provide a short and direct response. 1.53. What is the ratio of the Electricity production(% of total) of Croatia in 2007 to that in 2011?
Your answer should be very brief. 0.84. What is the ratio of the Electricity production(% of total) in Denmark in 2007 to that in 2011?
Ensure brevity in your answer.  1.48. What is the ratio of the Electricity production(% of total) of Georgia in 2007 to that in 2011?
Your response must be concise. 1.06. What is the ratio of the Electricity production(% of total) in Middle East & North Africa (developing only) in 2007 to that in 2012?
Your answer should be compact. 1.52. What is the ratio of the Electricity production(% of total) in Croatia in 2007 to that in 2012?
Provide a succinct answer. 0.79. What is the ratio of the Electricity production(% of total) of Denmark in 2007 to that in 2012?
Your answer should be compact. 1.29. What is the ratio of the Electricity production(% of total) in Georgia in 2007 to that in 2012?
Offer a very short reply. 1.1. What is the ratio of the Electricity production(% of total) in Middle East & North Africa (developing only) in 2008 to that in 2009?
Your answer should be compact. 1.01. What is the ratio of the Electricity production(% of total) of Croatia in 2008 to that in 2009?
Your answer should be very brief. 0.81. What is the ratio of the Electricity production(% of total) in Denmark in 2008 to that in 2009?
Your response must be concise. 1.36. What is the ratio of the Electricity production(% of total) in Georgia in 2008 to that in 2009?
Ensure brevity in your answer.  0.98. What is the ratio of the Electricity production(% of total) in Middle East & North Africa (developing only) in 2008 to that in 2010?
Make the answer very short. 0.9. What is the ratio of the Electricity production(% of total) in Croatia in 2008 to that in 2010?
Provide a succinct answer. 0.72. What is the ratio of the Electricity production(% of total) in Denmark in 2008 to that in 2010?
Provide a short and direct response. 1.31. What is the ratio of the Electricity production(% of total) in Georgia in 2008 to that in 2010?
Provide a short and direct response. 0.92. What is the ratio of the Electricity production(% of total) in Middle East & North Africa (developing only) in 2008 to that in 2011?
Ensure brevity in your answer.  0.89. What is the ratio of the Electricity production(% of total) of Croatia in 2008 to that in 2011?
Ensure brevity in your answer.  1.02. What is the ratio of the Electricity production(% of total) of Denmark in 2008 to that in 2011?
Offer a terse response. 1.47. What is the ratio of the Electricity production(% of total) in Georgia in 2008 to that in 2011?
Your response must be concise. 1.09. What is the ratio of the Electricity production(% of total) in Middle East & North Africa (developing only) in 2008 to that in 2012?
Your response must be concise. 0.89. What is the ratio of the Electricity production(% of total) of Croatia in 2008 to that in 2012?
Offer a terse response. 0.96. What is the ratio of the Electricity production(% of total) in Denmark in 2008 to that in 2012?
Provide a succinct answer. 1.28. What is the ratio of the Electricity production(% of total) in Georgia in 2008 to that in 2012?
Give a very brief answer. 1.14. What is the ratio of the Electricity production(% of total) in Middle East & North Africa (developing only) in 2009 to that in 2010?
Your response must be concise. 0.9. What is the ratio of the Electricity production(% of total) of Croatia in 2009 to that in 2010?
Offer a very short reply. 0.89. What is the ratio of the Electricity production(% of total) in Denmark in 2009 to that in 2010?
Give a very brief answer. 0.97. What is the ratio of the Electricity production(% of total) in Georgia in 2009 to that in 2010?
Offer a very short reply. 0.94. What is the ratio of the Electricity production(% of total) in Middle East & North Africa (developing only) in 2009 to that in 2011?
Your answer should be very brief. 0.89. What is the ratio of the Electricity production(% of total) of Croatia in 2009 to that in 2011?
Your answer should be very brief. 1.26. What is the ratio of the Electricity production(% of total) in Denmark in 2009 to that in 2011?
Provide a short and direct response. 1.08. What is the ratio of the Electricity production(% of total) of Georgia in 2009 to that in 2011?
Offer a terse response. 1.12. What is the ratio of the Electricity production(% of total) in Middle East & North Africa (developing only) in 2009 to that in 2012?
Provide a succinct answer. 0.88. What is the ratio of the Electricity production(% of total) of Croatia in 2009 to that in 2012?
Offer a terse response. 1.19. What is the ratio of the Electricity production(% of total) of Denmark in 2009 to that in 2012?
Keep it short and to the point. 0.94. What is the ratio of the Electricity production(% of total) of Georgia in 2009 to that in 2012?
Offer a terse response. 1.16. What is the ratio of the Electricity production(% of total) in Middle East & North Africa (developing only) in 2010 to that in 2011?
Your response must be concise. 0.99. What is the ratio of the Electricity production(% of total) in Croatia in 2010 to that in 2011?
Your response must be concise. 1.42. What is the ratio of the Electricity production(% of total) in Denmark in 2010 to that in 2011?
Your answer should be very brief. 1.12. What is the ratio of the Electricity production(% of total) of Georgia in 2010 to that in 2011?
Your answer should be very brief. 1.2. What is the ratio of the Electricity production(% of total) in Middle East & North Africa (developing only) in 2010 to that in 2012?
Provide a succinct answer. 0.99. What is the ratio of the Electricity production(% of total) of Croatia in 2010 to that in 2012?
Give a very brief answer. 1.33. What is the ratio of the Electricity production(% of total) in Denmark in 2010 to that in 2012?
Keep it short and to the point. 0.98. What is the ratio of the Electricity production(% of total) in Georgia in 2010 to that in 2012?
Provide a short and direct response. 1.24. What is the ratio of the Electricity production(% of total) in Middle East & North Africa (developing only) in 2011 to that in 2012?
Provide a succinct answer. 1. What is the ratio of the Electricity production(% of total) in Croatia in 2011 to that in 2012?
Make the answer very short. 0.94. What is the ratio of the Electricity production(% of total) in Denmark in 2011 to that in 2012?
Provide a short and direct response. 0.87. What is the ratio of the Electricity production(% of total) in Georgia in 2011 to that in 2012?
Offer a terse response. 1.04. What is the difference between the highest and the second highest Electricity production(% of total) in Middle East & North Africa (developing only)?
Offer a very short reply. 0.23. What is the difference between the highest and the second highest Electricity production(% of total) in Croatia?
Provide a short and direct response. 6.47. What is the difference between the highest and the second highest Electricity production(% of total) of Denmark?
Your response must be concise. 0. What is the difference between the highest and the second highest Electricity production(% of total) of Georgia?
Offer a terse response. 5.91. What is the difference between the highest and the lowest Electricity production(% of total) in Middle East & North Africa (developing only)?
Your response must be concise. 3.74. What is the difference between the highest and the lowest Electricity production(% of total) of Croatia?
Your answer should be compact. 24.43. What is the difference between the highest and the lowest Electricity production(% of total) of Denmark?
Your answer should be very brief. 0.02. What is the difference between the highest and the lowest Electricity production(% of total) of Georgia?
Keep it short and to the point. 19.58. 